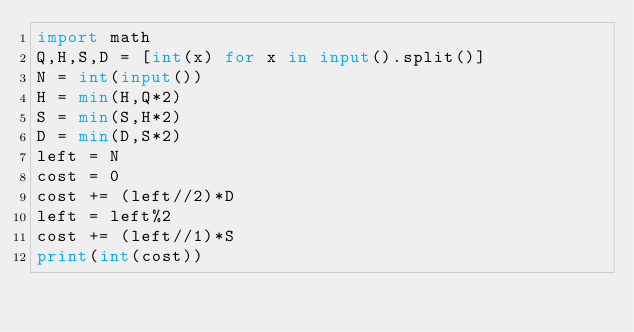Convert code to text. <code><loc_0><loc_0><loc_500><loc_500><_Python_>import math
Q,H,S,D = [int(x) for x in input().split()]
N = int(input())
H = min(H,Q*2)
S = min(S,H*2)
D = min(D,S*2)
left = N
cost = 0
cost += (left//2)*D
left = left%2
cost += (left//1)*S
print(int(cost))
</code> 